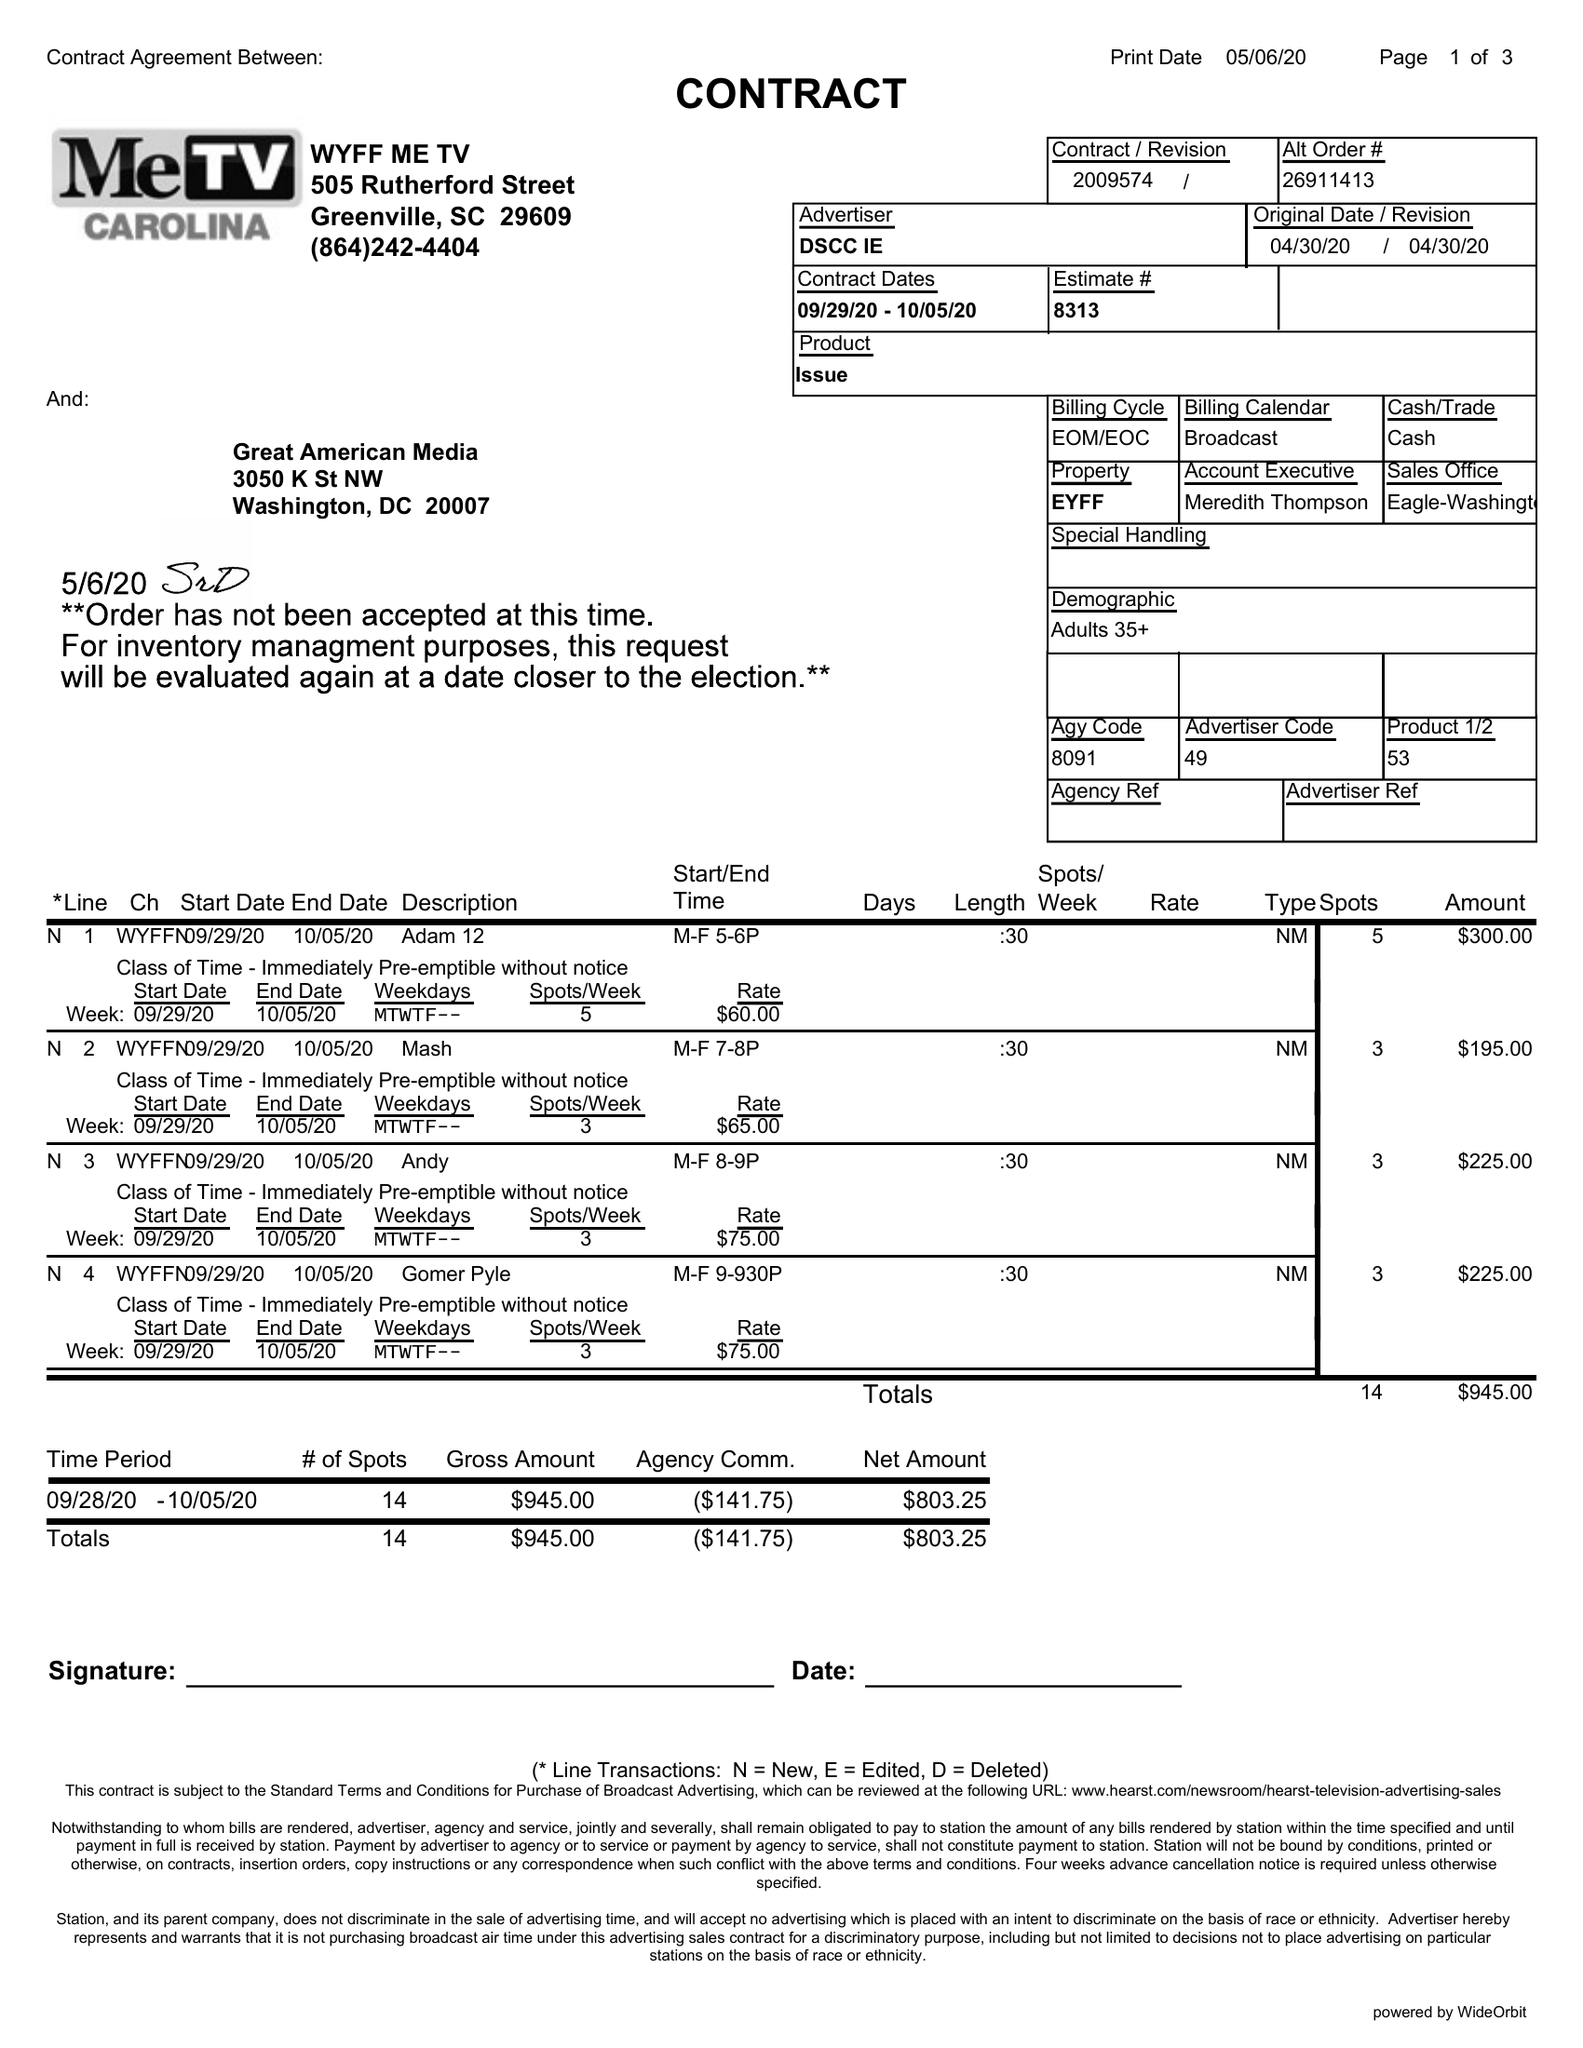What is the value for the flight_from?
Answer the question using a single word or phrase. 09/29/20 